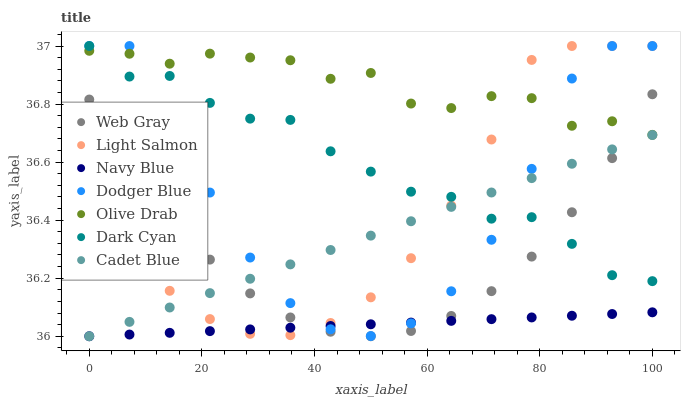Does Navy Blue have the minimum area under the curve?
Answer yes or no. Yes. Does Olive Drab have the maximum area under the curve?
Answer yes or no. Yes. Does Web Gray have the minimum area under the curve?
Answer yes or no. No. Does Web Gray have the maximum area under the curve?
Answer yes or no. No. Is Navy Blue the smoothest?
Answer yes or no. Yes. Is Dodger Blue the roughest?
Answer yes or no. Yes. Is Web Gray the smoothest?
Answer yes or no. No. Is Web Gray the roughest?
Answer yes or no. No. Does Navy Blue have the lowest value?
Answer yes or no. Yes. Does Web Gray have the lowest value?
Answer yes or no. No. Does Dark Cyan have the highest value?
Answer yes or no. Yes. Does Web Gray have the highest value?
Answer yes or no. No. Is Web Gray less than Dodger Blue?
Answer yes or no. Yes. Is Dodger Blue greater than Web Gray?
Answer yes or no. Yes. Does Navy Blue intersect Dodger Blue?
Answer yes or no. Yes. Is Navy Blue less than Dodger Blue?
Answer yes or no. No. Is Navy Blue greater than Dodger Blue?
Answer yes or no. No. Does Web Gray intersect Dodger Blue?
Answer yes or no. No. 